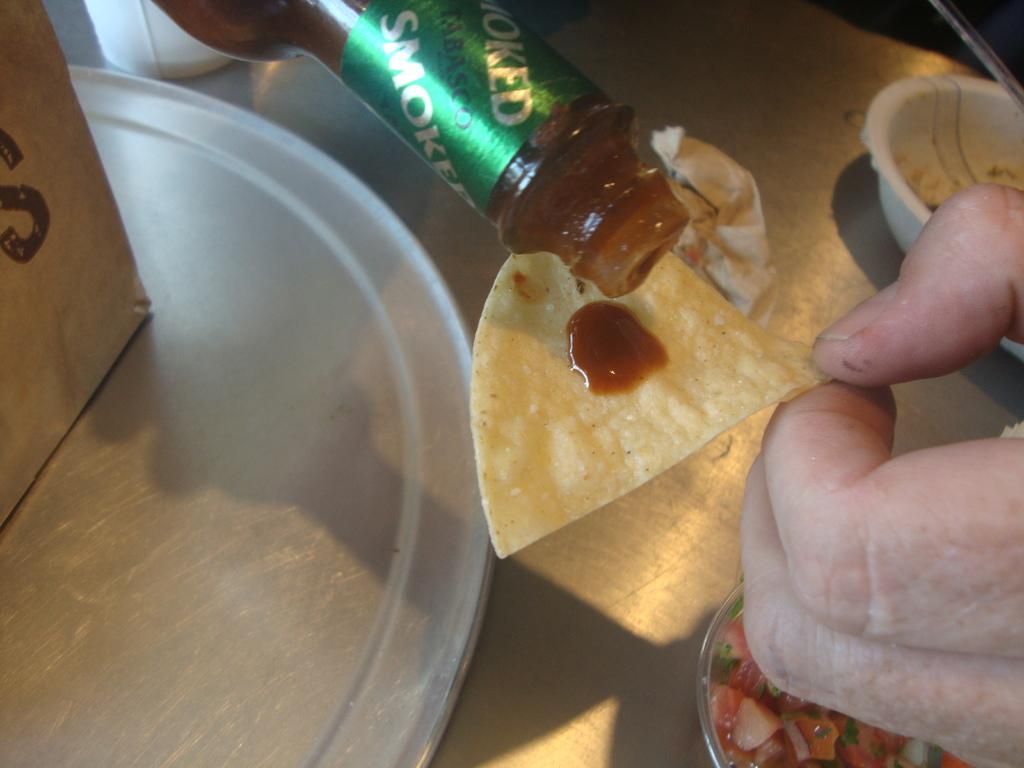<image>
Render a clear and concise summary of the photo. Someone pouring Smoked Tabasco sauce on to a tortilla chip. 